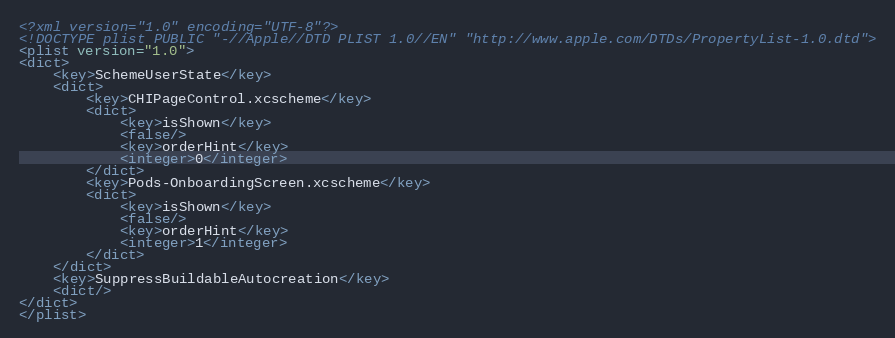<code> <loc_0><loc_0><loc_500><loc_500><_XML_><?xml version="1.0" encoding="UTF-8"?>
<!DOCTYPE plist PUBLIC "-//Apple//DTD PLIST 1.0//EN" "http://www.apple.com/DTDs/PropertyList-1.0.dtd">
<plist version="1.0">
<dict>
	<key>SchemeUserState</key>
	<dict>
		<key>CHIPageControl.xcscheme</key>
		<dict>
			<key>isShown</key>
			<false/>
			<key>orderHint</key>
			<integer>0</integer>
		</dict>
		<key>Pods-OnboardingScreen.xcscheme</key>
		<dict>
			<key>isShown</key>
			<false/>
			<key>orderHint</key>
			<integer>1</integer>
		</dict>
	</dict>
	<key>SuppressBuildableAutocreation</key>
	<dict/>
</dict>
</plist>
</code> 